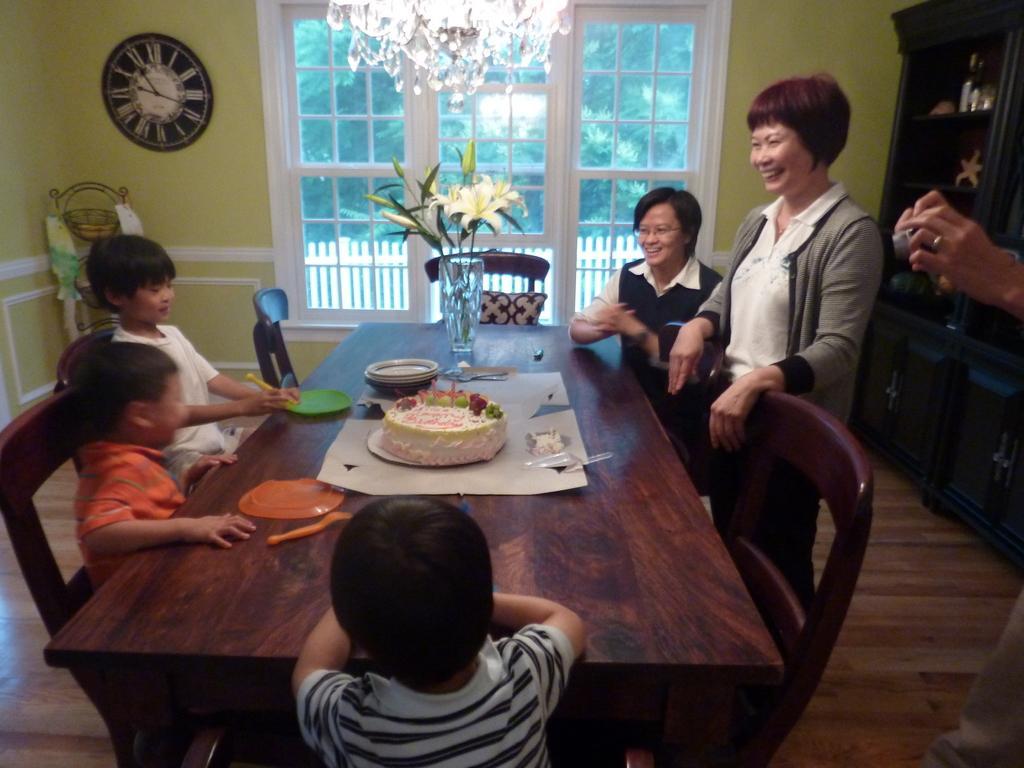Please provide a concise description of this image. In this image i can see few people sitting on chairs in front of a dining table and a woman standing on the table i can see a cake, few plates and a flower vase. In the background i can see a wall, a clock , a chandelier and a window through which i can see trees. To the right of the image i can see a person's hand holding a camera and the roof. 